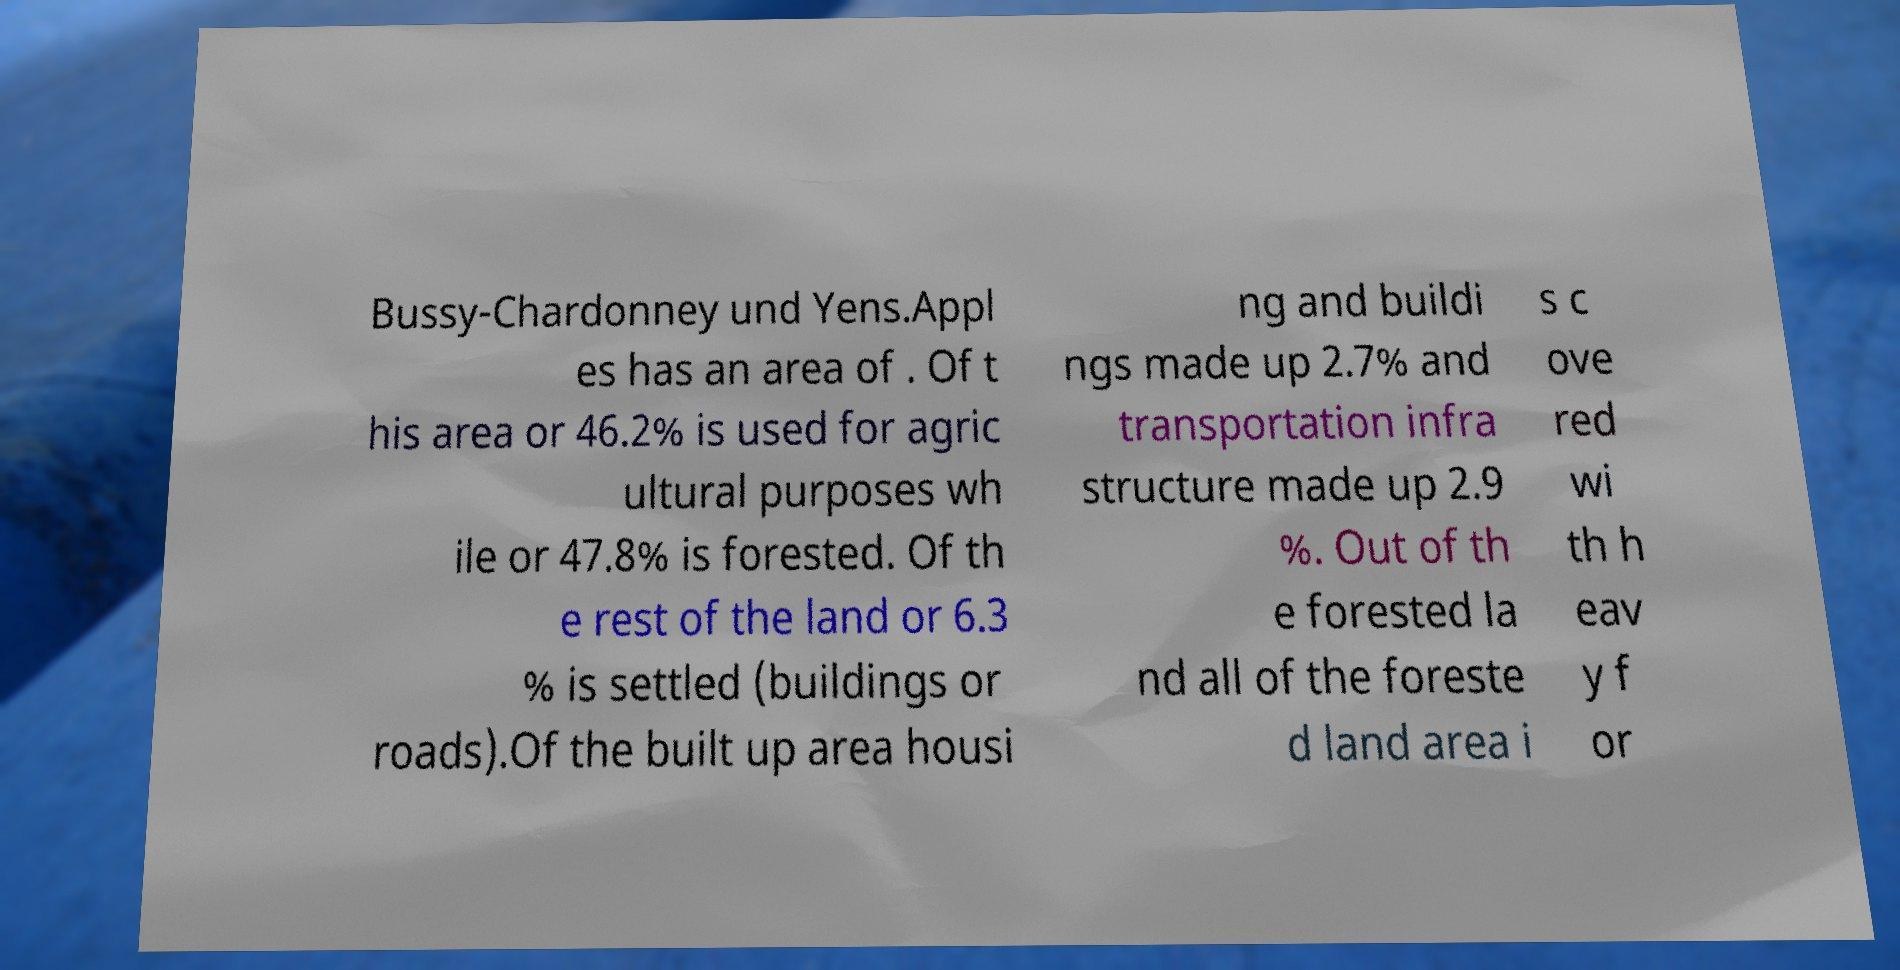Can you read and provide the text displayed in the image?This photo seems to have some interesting text. Can you extract and type it out for me? Bussy-Chardonney und Yens.Appl es has an area of . Of t his area or 46.2% is used for agric ultural purposes wh ile or 47.8% is forested. Of th e rest of the land or 6.3 % is settled (buildings or roads).Of the built up area housi ng and buildi ngs made up 2.7% and transportation infra structure made up 2.9 %. Out of th e forested la nd all of the foreste d land area i s c ove red wi th h eav y f or 